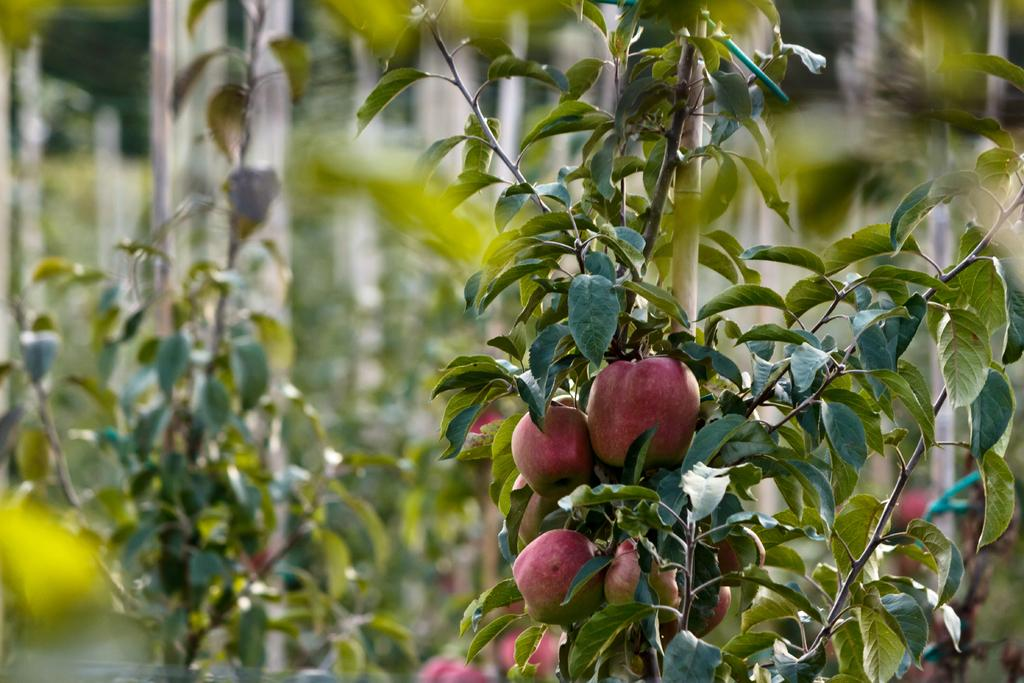What is the main subject of the image? There is a plant with fruits in the image. What can be seen in the background of the image? There are trees in the background of the image. How is the background of the image depicted? The background is blurred. What type of animal can be seen playing with a spade in the image? There is no animal or spade present in the image; it features a plant with fruits and a blurred background. How many babies are visible in the image? There are no babies present in the image. 